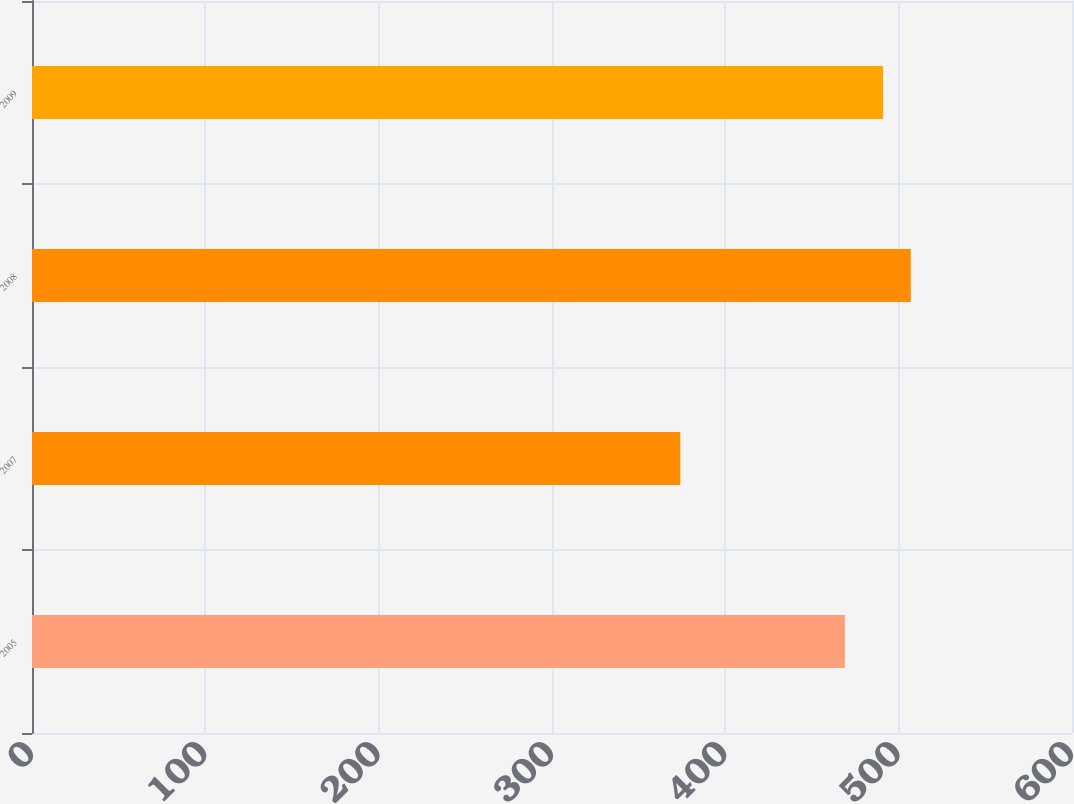<chart> <loc_0><loc_0><loc_500><loc_500><bar_chart><fcel>2005<fcel>2007<fcel>2008<fcel>2009<nl><fcel>469<fcel>374<fcel>507<fcel>491<nl></chart> 